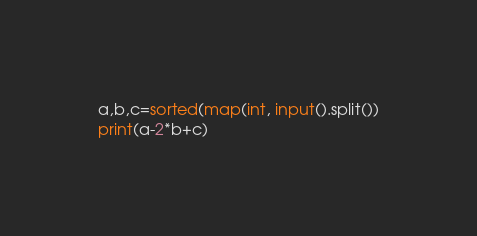Convert code to text. <code><loc_0><loc_0><loc_500><loc_500><_Python_>a,b,c=sorted(map(int, input().split())
print(a-2*b+c)</code> 